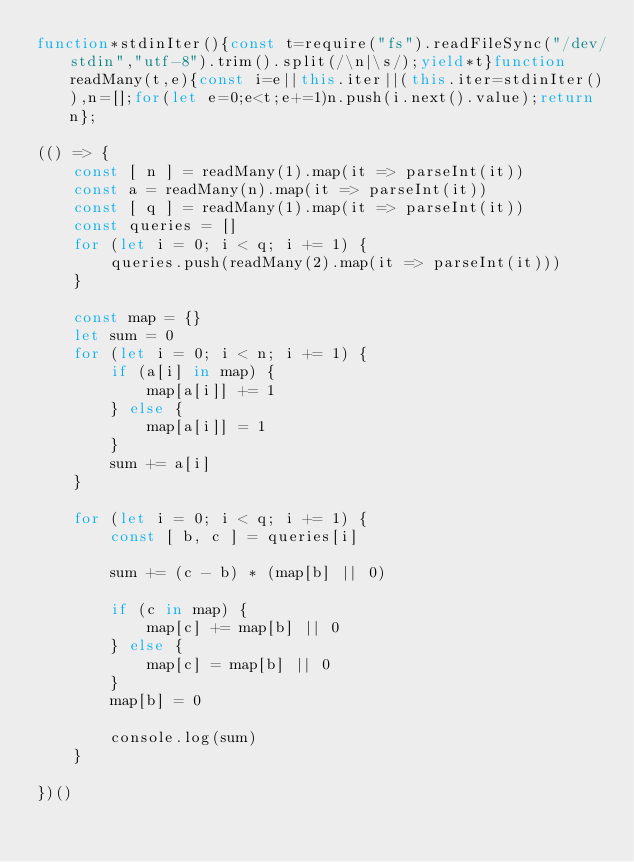Convert code to text. <code><loc_0><loc_0><loc_500><loc_500><_JavaScript_>function*stdinIter(){const t=require("fs").readFileSync("/dev/stdin","utf-8").trim().split(/\n|\s/);yield*t}function readMany(t,e){const i=e||this.iter||(this.iter=stdinIter()),n=[];for(let e=0;e<t;e+=1)n.push(i.next().value);return n};

(() => {
    const [ n ] = readMany(1).map(it => parseInt(it))
    const a = readMany(n).map(it => parseInt(it))
    const [ q ] = readMany(1).map(it => parseInt(it))
    const queries = []
    for (let i = 0; i < q; i += 1) {
        queries.push(readMany(2).map(it => parseInt(it)))
    }

    const map = {}
    let sum = 0
    for (let i = 0; i < n; i += 1) {
        if (a[i] in map) {
            map[a[i]] += 1
        } else {
            map[a[i]] = 1
        }
        sum += a[i]
    }

    for (let i = 0; i < q; i += 1) {
        const [ b, c ] = queries[i]

        sum += (c - b) * (map[b] || 0)

        if (c in map) {
            map[c] += map[b] || 0
        } else {
            map[c] = map[b] || 0
        }
        map[b] = 0

        console.log(sum)
    }

})()
</code> 